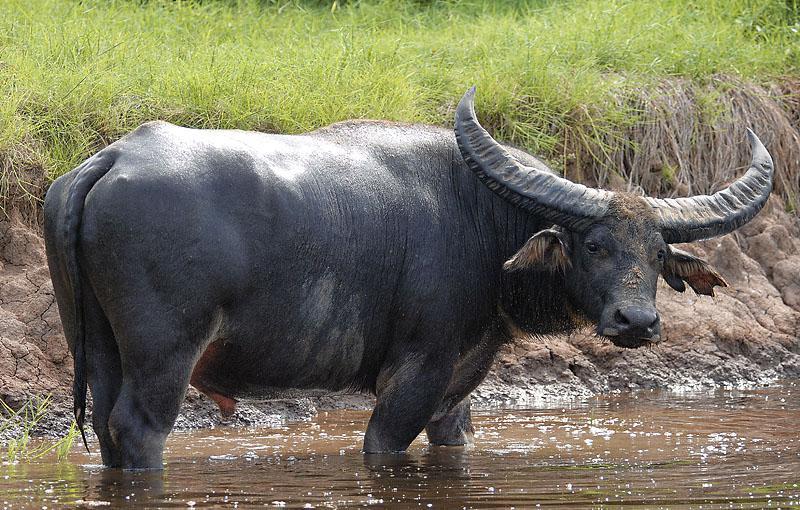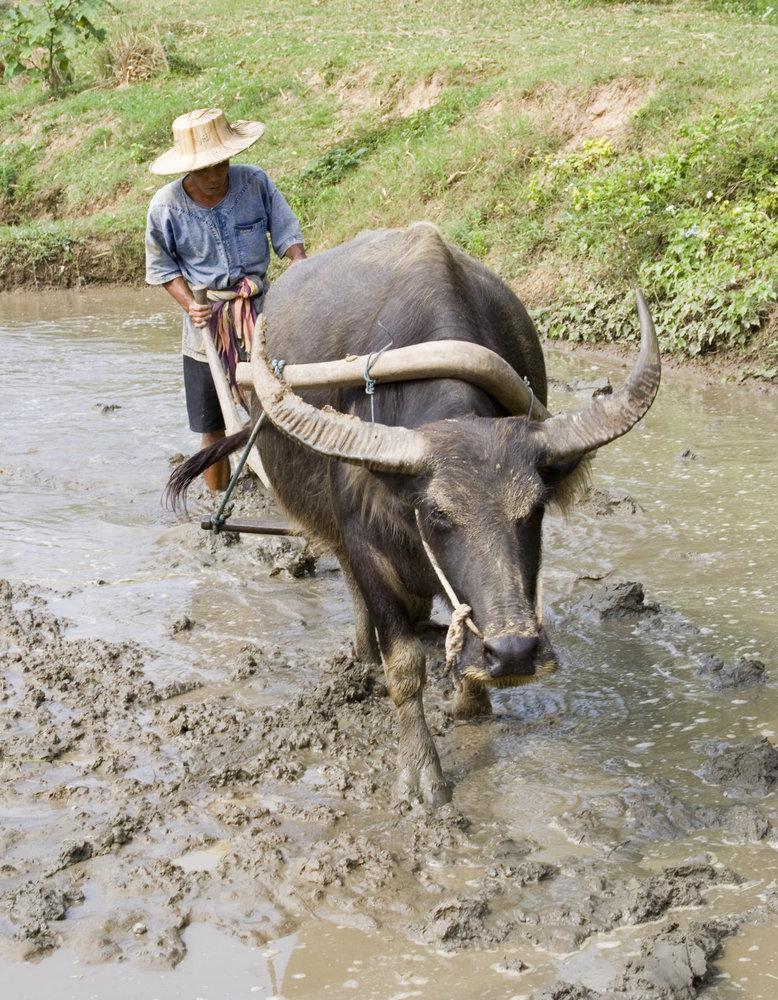The first image is the image on the left, the second image is the image on the right. Examine the images to the left and right. Is the description "At least 1 cattle is submerged to the shoulder." accurate? Answer yes or no. No. 